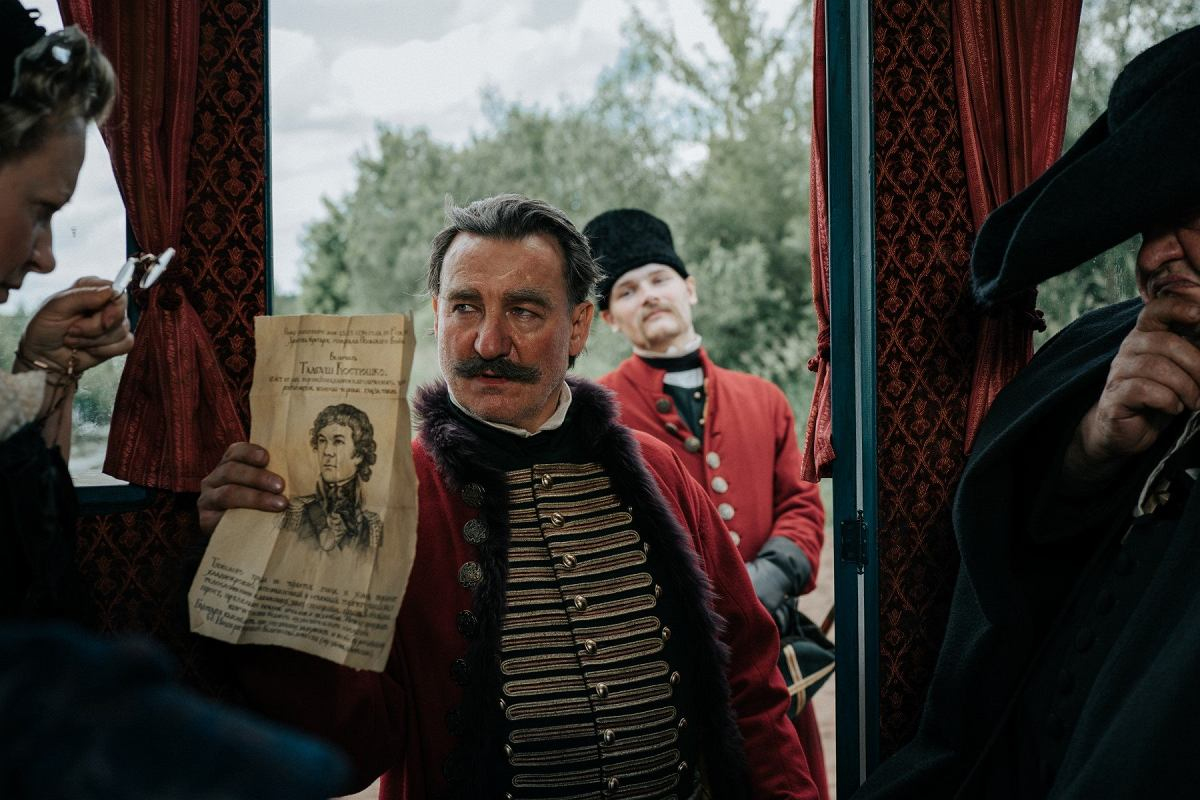Discuss the possible historical period and location this scene might be representing. This scene likely represents a historical period in the 19th century, judging by the style of the military uniforms and the overall setting. The lush greenery visible through the window and the style of the curtains suggest a location in Europe, possibly Eastern Europe. Such a setting could be portraying a significant historical event or a fictional account set during a turbulent period, adding layers of narrative depth and cultural context. 